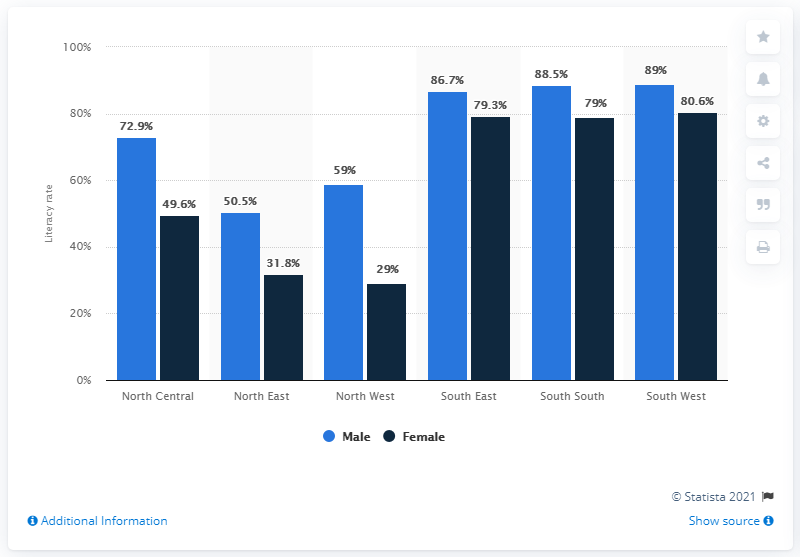List a handful of essential elements in this visual. In the South West region of Nigeria, approximately 88.5% of male residents are literate. 